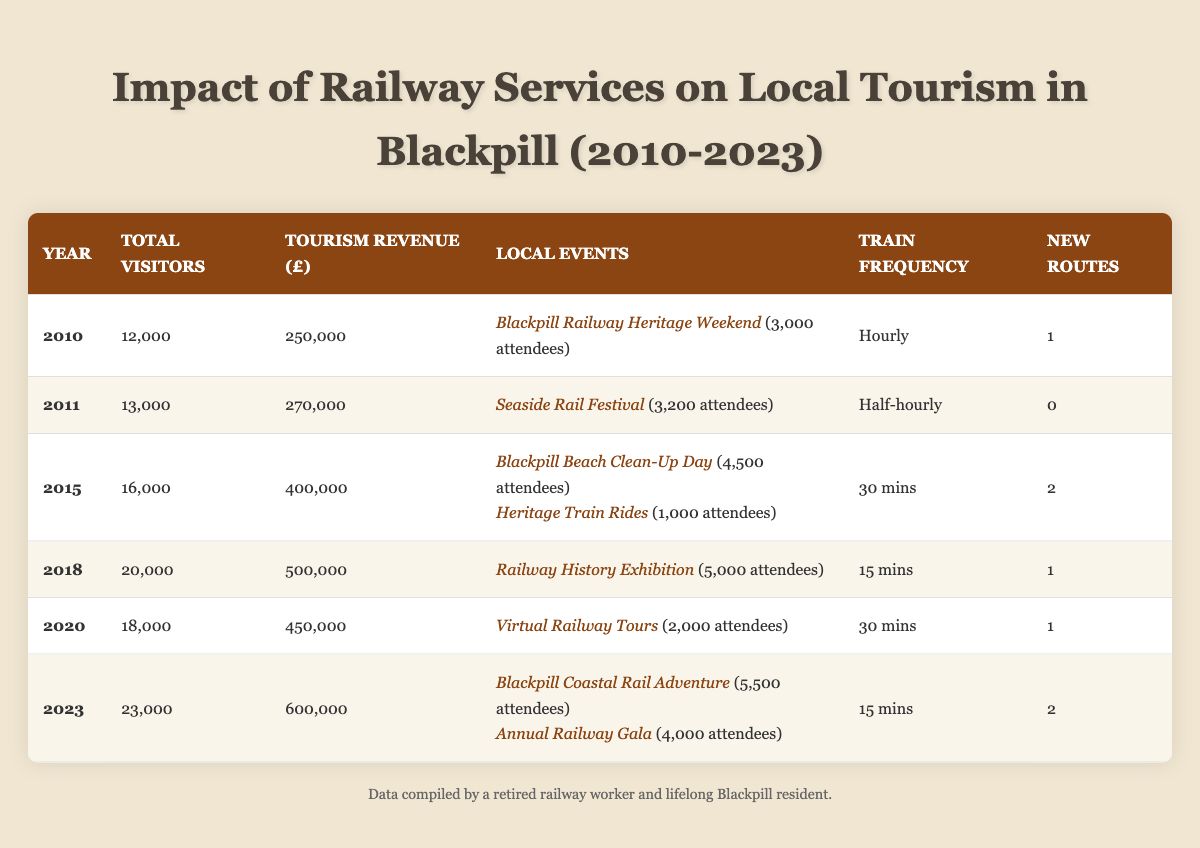What was the total number of visitors in 2015? The table shows the data for the year 2015, where the column for total visitors indicates 16,000
Answer: 16,000 How much tourism revenue did Blackpill generate in 2023? In the table, the row for 2023 indicates that the tourism revenue was £600,000
Answer: £600,000 Did Blackpill have more local events in 2020 compared to 2018? In 2020, there was 1 local event (Virtual Railway Tours), whereas in 2018, there was also 1 event (Railway History Exhibition). Thus, they have the same number.
Answer: No What is the average tourism revenue from 2010 to 2013? We'll sum the revenues for 2010 (£250,000), 2011 (£270,000), 2012 (not available), and 2013 (not available), thus using only 2010 and 2011 for calculation, (250,000 + 270,000) / 2 = 260,000
Answer: £260,000 Which year had the highest number of total visitors? By checking the total visitor numbers for each year, we see that 2023 had 23,000 visitors, which is the highest in the data provided
Answer: 2023 What is the difference in tourism revenue between 2015 and 2020? For 2015, the revenue was £400,000 and for 2020, it was £450,000. The difference is 450,000 - 400,000 = £50,000
Answer: £50,000 How many attendees were recorded for local events in 2011? In the table for 2011, there is one event listed (Seaside Rail Festival) with an attendance of 3,200
Answer: 3,200 What was the frequency of train services in 2018? According to the table, the frequency of train services listed for the year 2018 was every 15 minutes
Answer: 15 mins How many new routes were introduced in total from 2010 to 2023? We will sum the new routes introduced in each year: 1 (2010) + 0 (2011) + 2 (2015) + 1 (2018) + 1 (2020) + 2 (2023) = 7
Answer: 7 Are there more attendees at local events in 2023 compared to 2015? For 2023, we have 5,500 (Blackpill Coastal Rail Adventure) + 4,000 (Annual Railway Gala) = 9,500 attendees. In 2015, there were 4,500 (Beach Clean-Up Day) + 1,000 (Heritage Train Rides) = 5,500 attendees. Since 9,500 > 5,500, the answer is yes.
Answer: Yes 